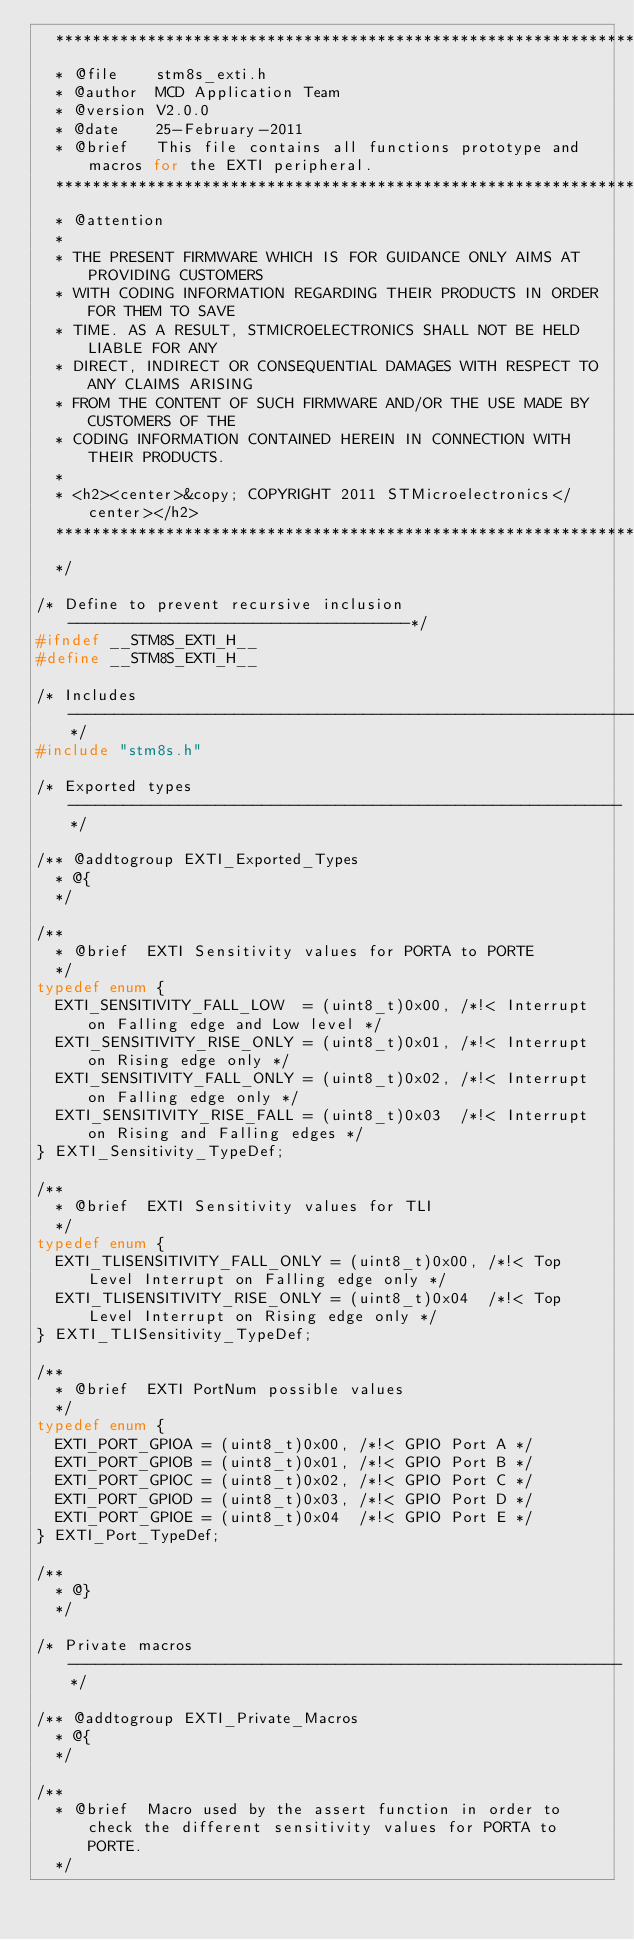<code> <loc_0><loc_0><loc_500><loc_500><_C_>  ******************************************************************************
  * @file    stm8s_exti.h
  * @author  MCD Application Team
  * @version V2.0.0
  * @date    25-February-2011
  * @brief   This file contains all functions prototype and macros for the EXTI peripheral.
  ******************************************************************************
  * @attention
  *
  * THE PRESENT FIRMWARE WHICH IS FOR GUIDANCE ONLY AIMS AT PROVIDING CUSTOMERS
  * WITH CODING INFORMATION REGARDING THEIR PRODUCTS IN ORDER FOR THEM TO SAVE
  * TIME. AS A RESULT, STMICROELECTRONICS SHALL NOT BE HELD LIABLE FOR ANY
  * DIRECT, INDIRECT OR CONSEQUENTIAL DAMAGES WITH RESPECT TO ANY CLAIMS ARISING
  * FROM THE CONTENT OF SUCH FIRMWARE AND/OR THE USE MADE BY CUSTOMERS OF THE
  * CODING INFORMATION CONTAINED HEREIN IN CONNECTION WITH THEIR PRODUCTS.
  *
  * <h2><center>&copy; COPYRIGHT 2011 STMicroelectronics</center></h2>
  ******************************************************************************
  */

/* Define to prevent recursive inclusion -------------------------------------*/
#ifndef __STM8S_EXTI_H__
#define __STM8S_EXTI_H__

/* Includes ------------------------------------------------------------------*/
#include "stm8s.h"

/* Exported types ------------------------------------------------------------*/

/** @addtogroup EXTI_Exported_Types
  * @{
  */

/**
  * @brief  EXTI Sensitivity values for PORTA to PORTE
  */
typedef enum {
  EXTI_SENSITIVITY_FALL_LOW  = (uint8_t)0x00, /*!< Interrupt on Falling edge and Low level */
  EXTI_SENSITIVITY_RISE_ONLY = (uint8_t)0x01, /*!< Interrupt on Rising edge only */
  EXTI_SENSITIVITY_FALL_ONLY = (uint8_t)0x02, /*!< Interrupt on Falling edge only */
  EXTI_SENSITIVITY_RISE_FALL = (uint8_t)0x03  /*!< Interrupt on Rising and Falling edges */
} EXTI_Sensitivity_TypeDef;

/**
  * @brief  EXTI Sensitivity values for TLI
  */
typedef enum {
  EXTI_TLISENSITIVITY_FALL_ONLY = (uint8_t)0x00, /*!< Top Level Interrupt on Falling edge only */
  EXTI_TLISENSITIVITY_RISE_ONLY = (uint8_t)0x04  /*!< Top Level Interrupt on Rising edge only */
} EXTI_TLISensitivity_TypeDef;

/**
  * @brief  EXTI PortNum possible values
  */
typedef enum {
  EXTI_PORT_GPIOA = (uint8_t)0x00, /*!< GPIO Port A */
  EXTI_PORT_GPIOB = (uint8_t)0x01, /*!< GPIO Port B */
  EXTI_PORT_GPIOC = (uint8_t)0x02, /*!< GPIO Port C */
  EXTI_PORT_GPIOD = (uint8_t)0x03, /*!< GPIO Port D */
  EXTI_PORT_GPIOE = (uint8_t)0x04  /*!< GPIO Port E */
} EXTI_Port_TypeDef;

/**
  * @}
  */

/* Private macros ------------------------------------------------------------*/

/** @addtogroup EXTI_Private_Macros
  * @{
  */

/**
  * @brief  Macro used by the assert function in order to check the different sensitivity values for PORTA to PORTE.
  */</code> 